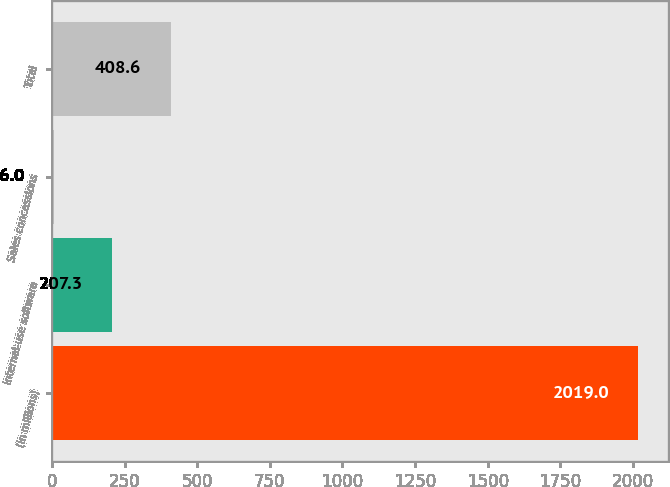Convert chart to OTSL. <chart><loc_0><loc_0><loc_500><loc_500><bar_chart><fcel>(in millions)<fcel>Internal-use software<fcel>Sales concessions<fcel>Total<nl><fcel>2019<fcel>207.3<fcel>6<fcel>408.6<nl></chart> 